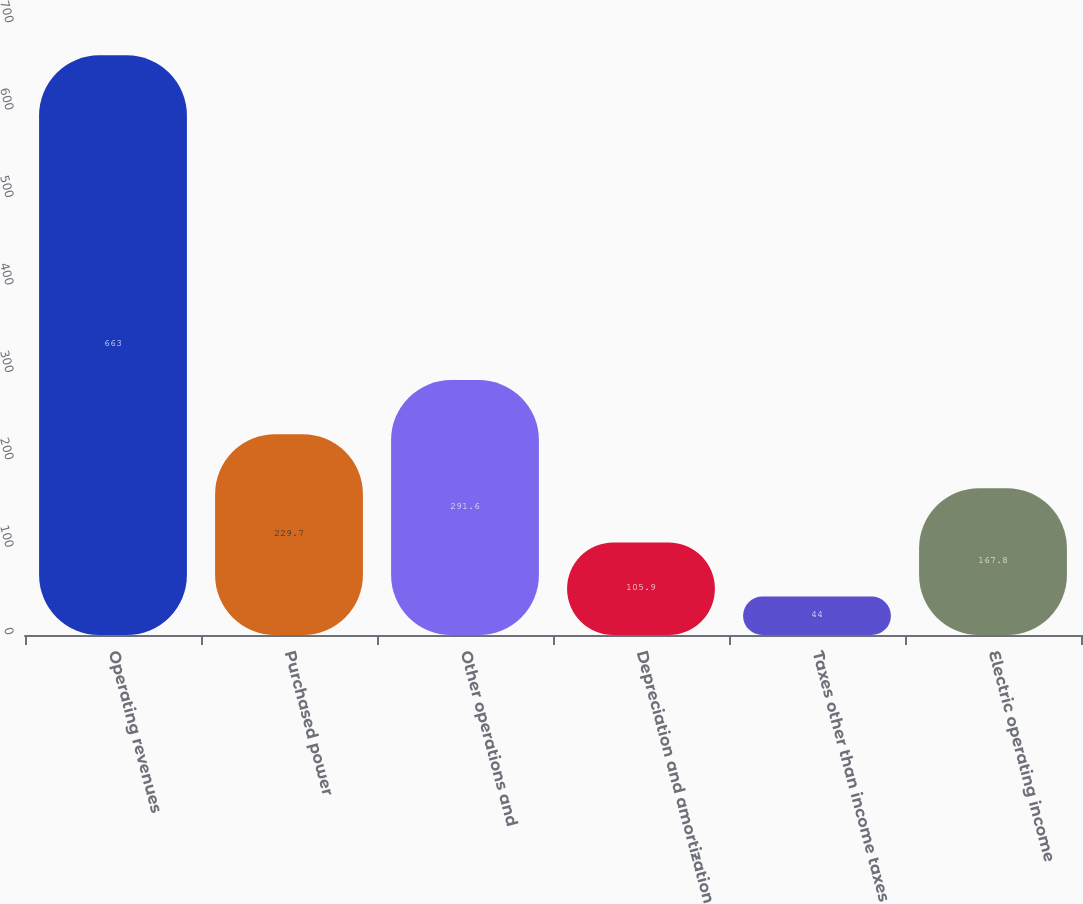Convert chart to OTSL. <chart><loc_0><loc_0><loc_500><loc_500><bar_chart><fcel>Operating revenues<fcel>Purchased power<fcel>Other operations and<fcel>Depreciation and amortization<fcel>Taxes other than income taxes<fcel>Electric operating income<nl><fcel>663<fcel>229.7<fcel>291.6<fcel>105.9<fcel>44<fcel>167.8<nl></chart> 